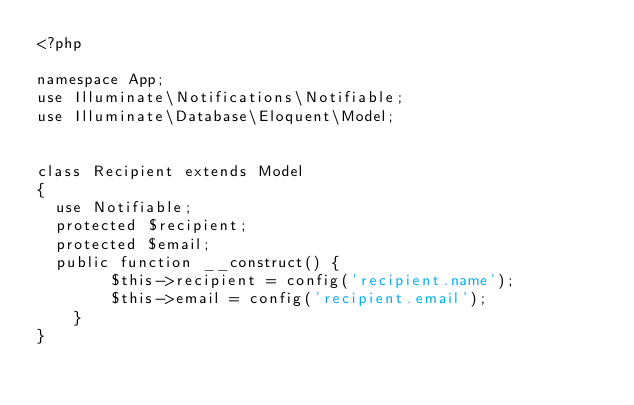Convert code to text. <code><loc_0><loc_0><loc_500><loc_500><_PHP_><?php

namespace App;
use Illuminate\Notifications\Notifiable;
use Illuminate\Database\Eloquent\Model;


class Recipient extends Model
{
  use Notifiable;
  protected $recipient;
  protected $email;
  public function __construct() {
        $this->recipient = config('recipient.name');
        $this->email = config('recipient.email');
    }
}</code> 